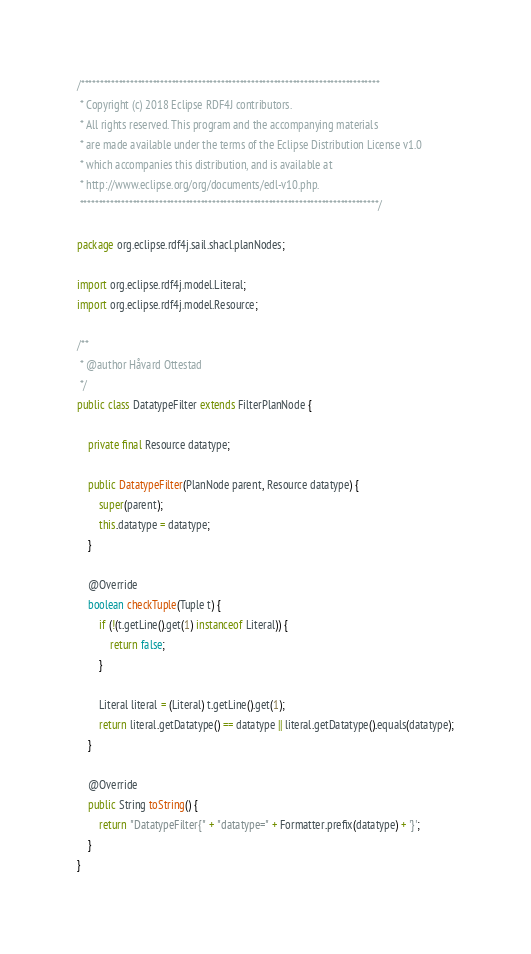Convert code to text. <code><loc_0><loc_0><loc_500><loc_500><_Java_>/*******************************************************************************
 * Copyright (c) 2018 Eclipse RDF4J contributors.
 * All rights reserved. This program and the accompanying materials
 * are made available under the terms of the Eclipse Distribution License v1.0
 * which accompanies this distribution, and is available at
 * http://www.eclipse.org/org/documents/edl-v10.php.
 *******************************************************************************/

package org.eclipse.rdf4j.sail.shacl.planNodes;

import org.eclipse.rdf4j.model.Literal;
import org.eclipse.rdf4j.model.Resource;

/**
 * @author Håvard Ottestad
 */
public class DatatypeFilter extends FilterPlanNode {

	private final Resource datatype;

	public DatatypeFilter(PlanNode parent, Resource datatype) {
		super(parent);
		this.datatype = datatype;
	}

	@Override
	boolean checkTuple(Tuple t) {
		if (!(t.getLine().get(1) instanceof Literal)) {
			return false;
		}

		Literal literal = (Literal) t.getLine().get(1);
		return literal.getDatatype() == datatype || literal.getDatatype().equals(datatype);
	}

	@Override
	public String toString() {
		return "DatatypeFilter{" + "datatype=" + Formatter.prefix(datatype) + '}';
	}
}
</code> 